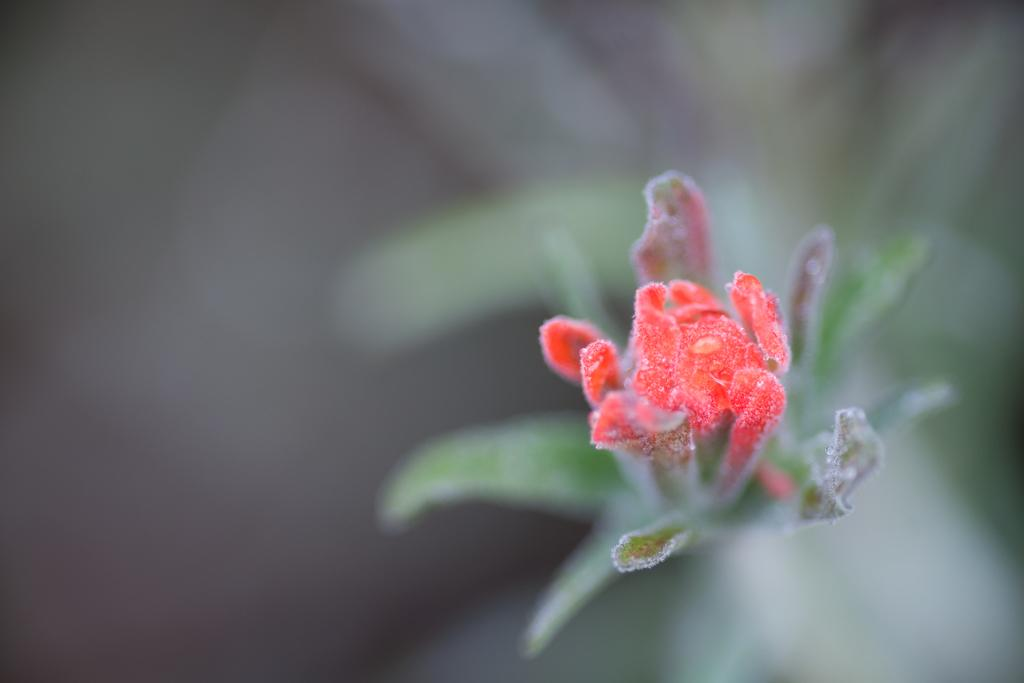What is located in the center of the image? There are leaves and a flower in the center of the image. What color is the flower in the image? The flower is red in color. Can you describe the type of vegetation present in the image? The image features leaves and a flower. What type of clam can be seen in the image? There are no clams present in the image; it features leaves and a red flower. What is the cause of the flower's red color in the image? The cause of the flower's red color is not mentioned in the image, but it could be due to the flower's natural pigmentation or other factors. 